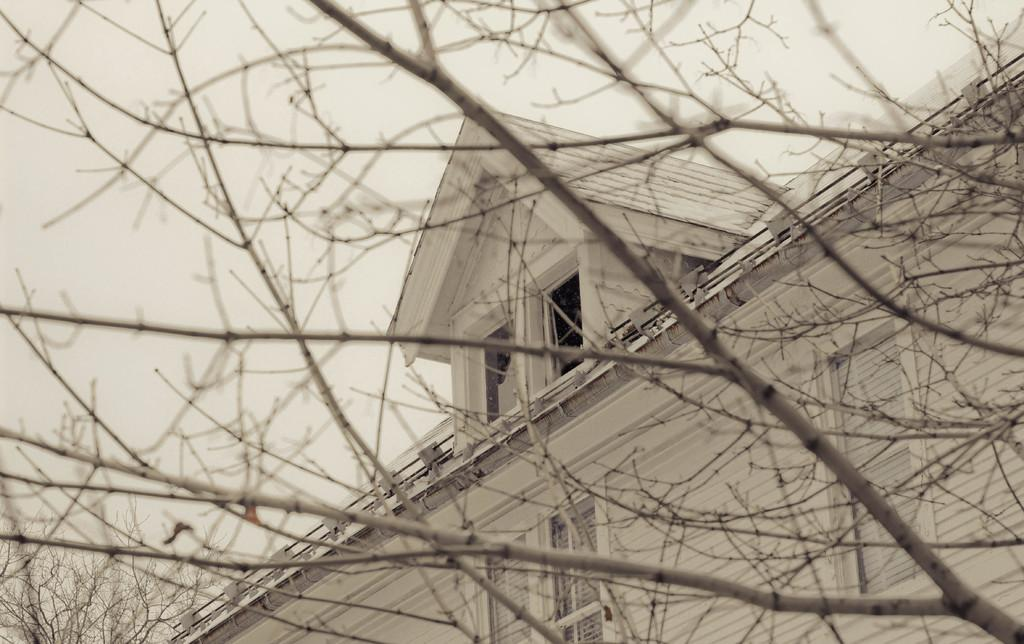What type of structure is present in the image? There is a house in the image. How many windows can be seen on the house? The house has multiple windows. What else is visible in the image besides the house? Branches of a tree are visible in the image. What type of grape is being distributed during the week in the image? There is no mention of grapes or distribution in the image; it features a house with multiple windows and tree branches. 